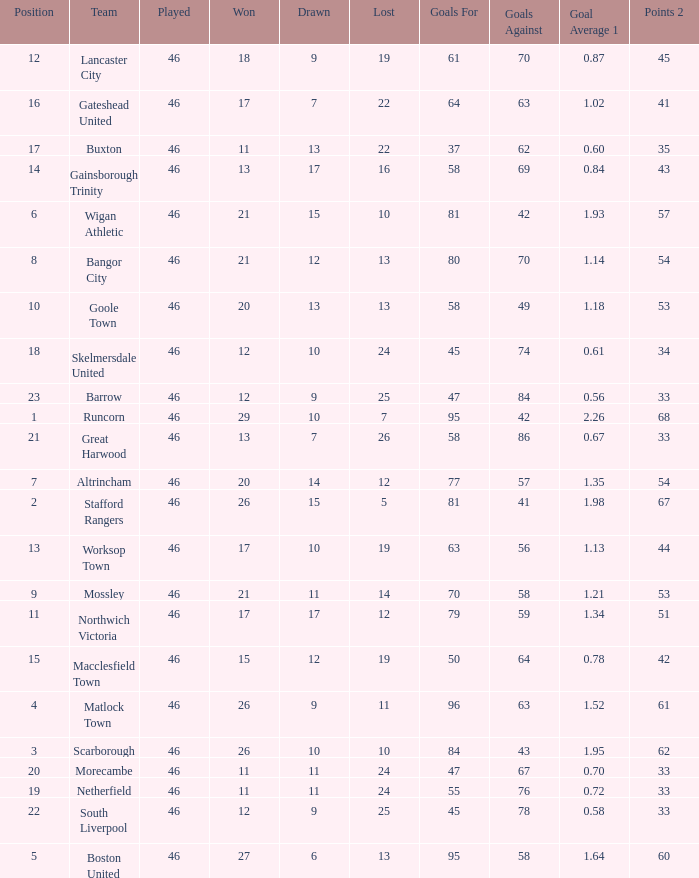Parse the table in full. {'header': ['Position', 'Team', 'Played', 'Won', 'Drawn', 'Lost', 'Goals For', 'Goals Against', 'Goal Average 1', 'Points 2'], 'rows': [['12', 'Lancaster City', '46', '18', '9', '19', '61', '70', '0.87', '45'], ['16', 'Gateshead United', '46', '17', '7', '22', '64', '63', '1.02', '41'], ['17', 'Buxton', '46', '11', '13', '22', '37', '62', '0.60', '35'], ['14', 'Gainsborough Trinity', '46', '13', '17', '16', '58', '69', '0.84', '43'], ['6', 'Wigan Athletic', '46', '21', '15', '10', '81', '42', '1.93', '57'], ['8', 'Bangor City', '46', '21', '12', '13', '80', '70', '1.14', '54'], ['10', 'Goole Town', '46', '20', '13', '13', '58', '49', '1.18', '53'], ['18', 'Skelmersdale United', '46', '12', '10', '24', '45', '74', '0.61', '34'], ['23', 'Barrow', '46', '12', '9', '25', '47', '84', '0.56', '33'], ['1', 'Runcorn', '46', '29', '10', '7', '95', '42', '2.26', '68'], ['21', 'Great Harwood', '46', '13', '7', '26', '58', '86', '0.67', '33'], ['7', 'Altrincham', '46', '20', '14', '12', '77', '57', '1.35', '54'], ['2', 'Stafford Rangers', '46', '26', '15', '5', '81', '41', '1.98', '67'], ['13', 'Worksop Town', '46', '17', '10', '19', '63', '56', '1.13', '44'], ['9', 'Mossley', '46', '21', '11', '14', '70', '58', '1.21', '53'], ['11', 'Northwich Victoria', '46', '17', '17', '12', '79', '59', '1.34', '51'], ['15', 'Macclesfield Town', '46', '15', '12', '19', '50', '64', '0.78', '42'], ['4', 'Matlock Town', '46', '26', '9', '11', '96', '63', '1.52', '61'], ['3', 'Scarborough', '46', '26', '10', '10', '84', '43', '1.95', '62'], ['20', 'Morecambe', '46', '11', '11', '24', '47', '67', '0.70', '33'], ['19', 'Netherfield', '46', '11', '11', '24', '55', '76', '0.72', '33'], ['22', 'South Liverpool', '46', '12', '9', '25', '45', '78', '0.58', '33'], ['5', 'Boston United', '46', '27', '6', '13', '95', '58', '1.64', '60']]} List all losses with average goals of 1.21. 14.0. 